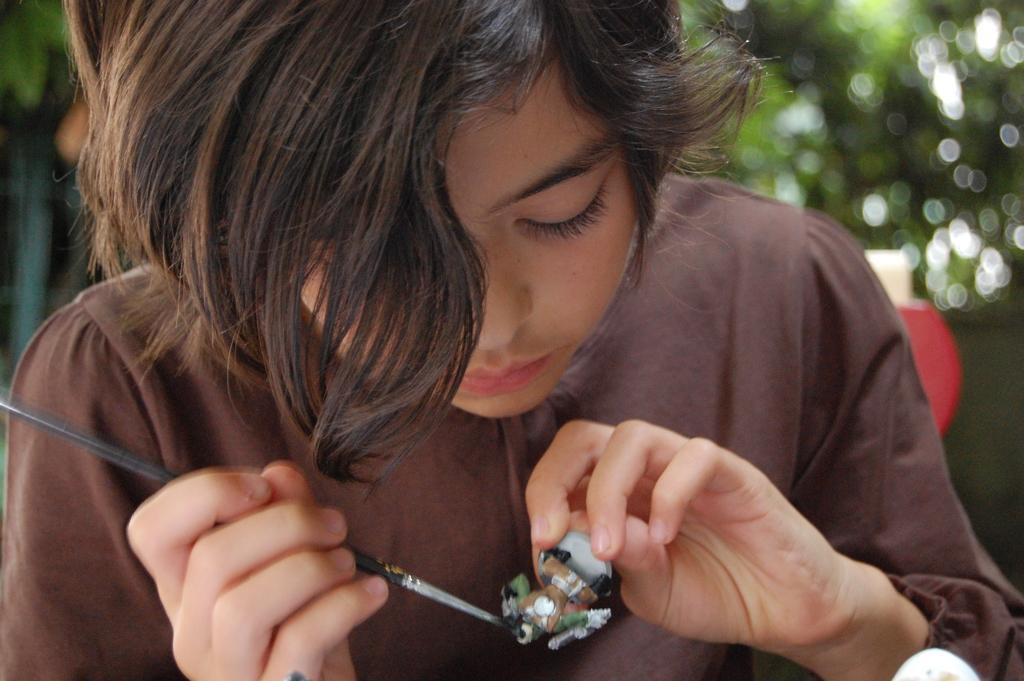Could you give a brief overview of what you see in this image? This woman is holding a toy and paint brush. She is looking at this toy. Background it is blur. We can see the tree.  